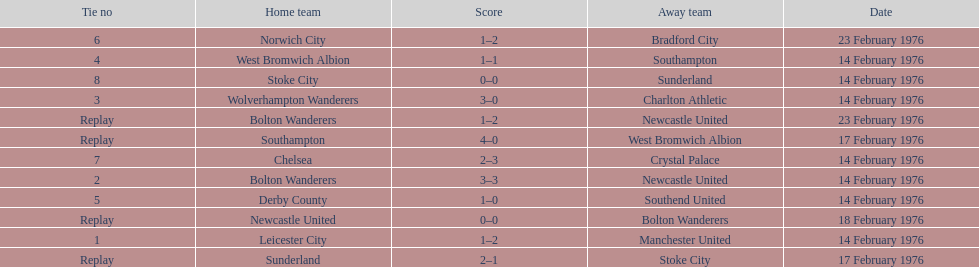What is the difference between southampton's score and sunderland's score? 2 goals. 